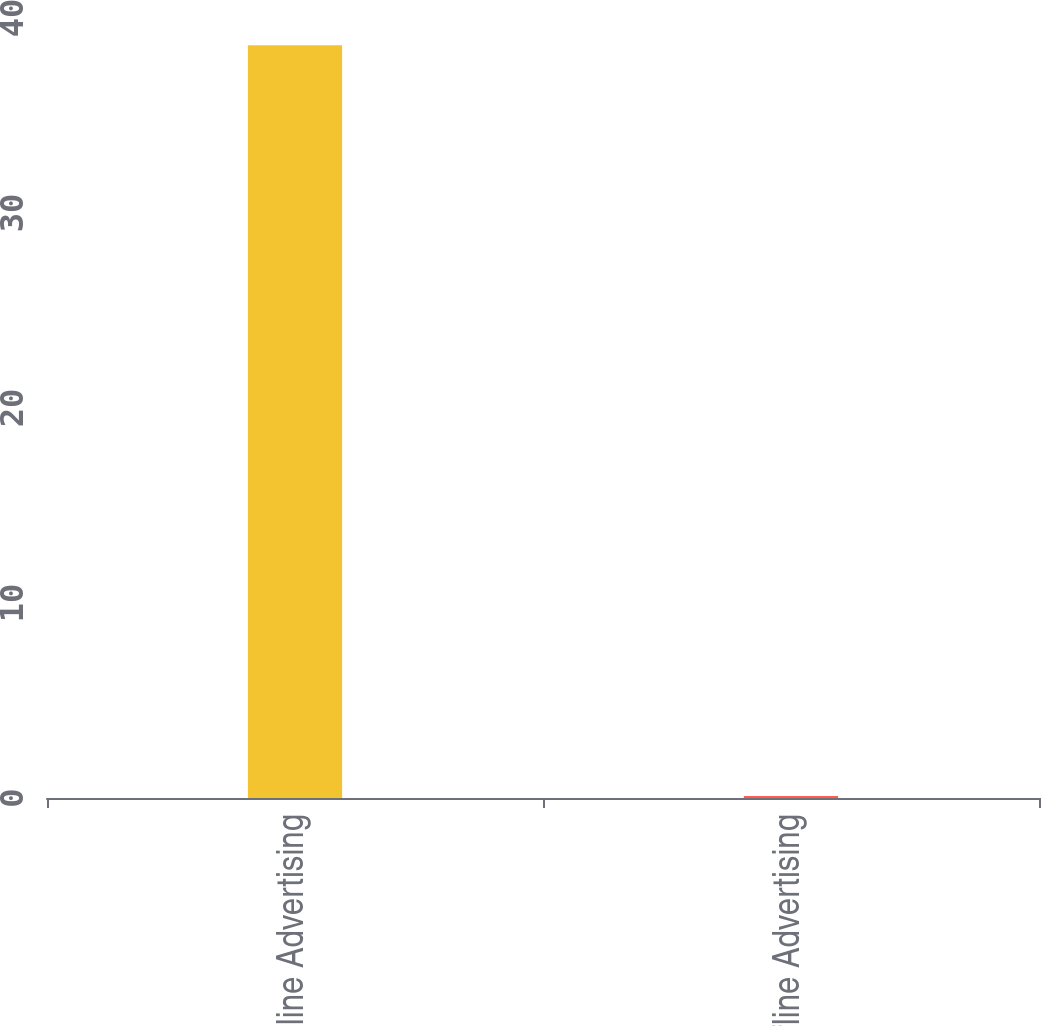<chart> <loc_0><loc_0><loc_500><loc_500><bar_chart><fcel>Online Advertising<fcel>Offline Advertising<nl><fcel>38.6<fcel>0.1<nl></chart> 